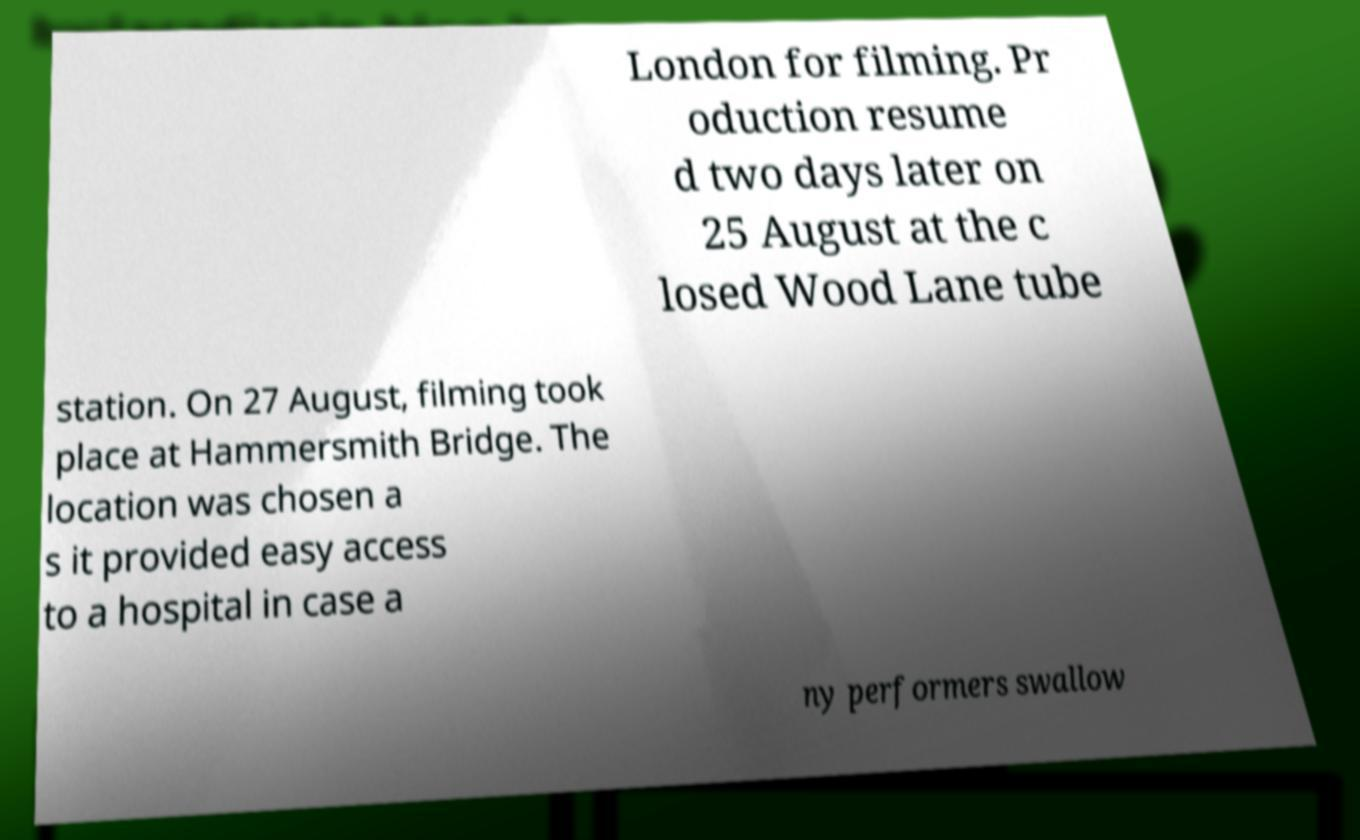Could you extract and type out the text from this image? London for filming. Pr oduction resume d two days later on 25 August at the c losed Wood Lane tube station. On 27 August, filming took place at Hammersmith Bridge. The location was chosen a s it provided easy access to a hospital in case a ny performers swallow 